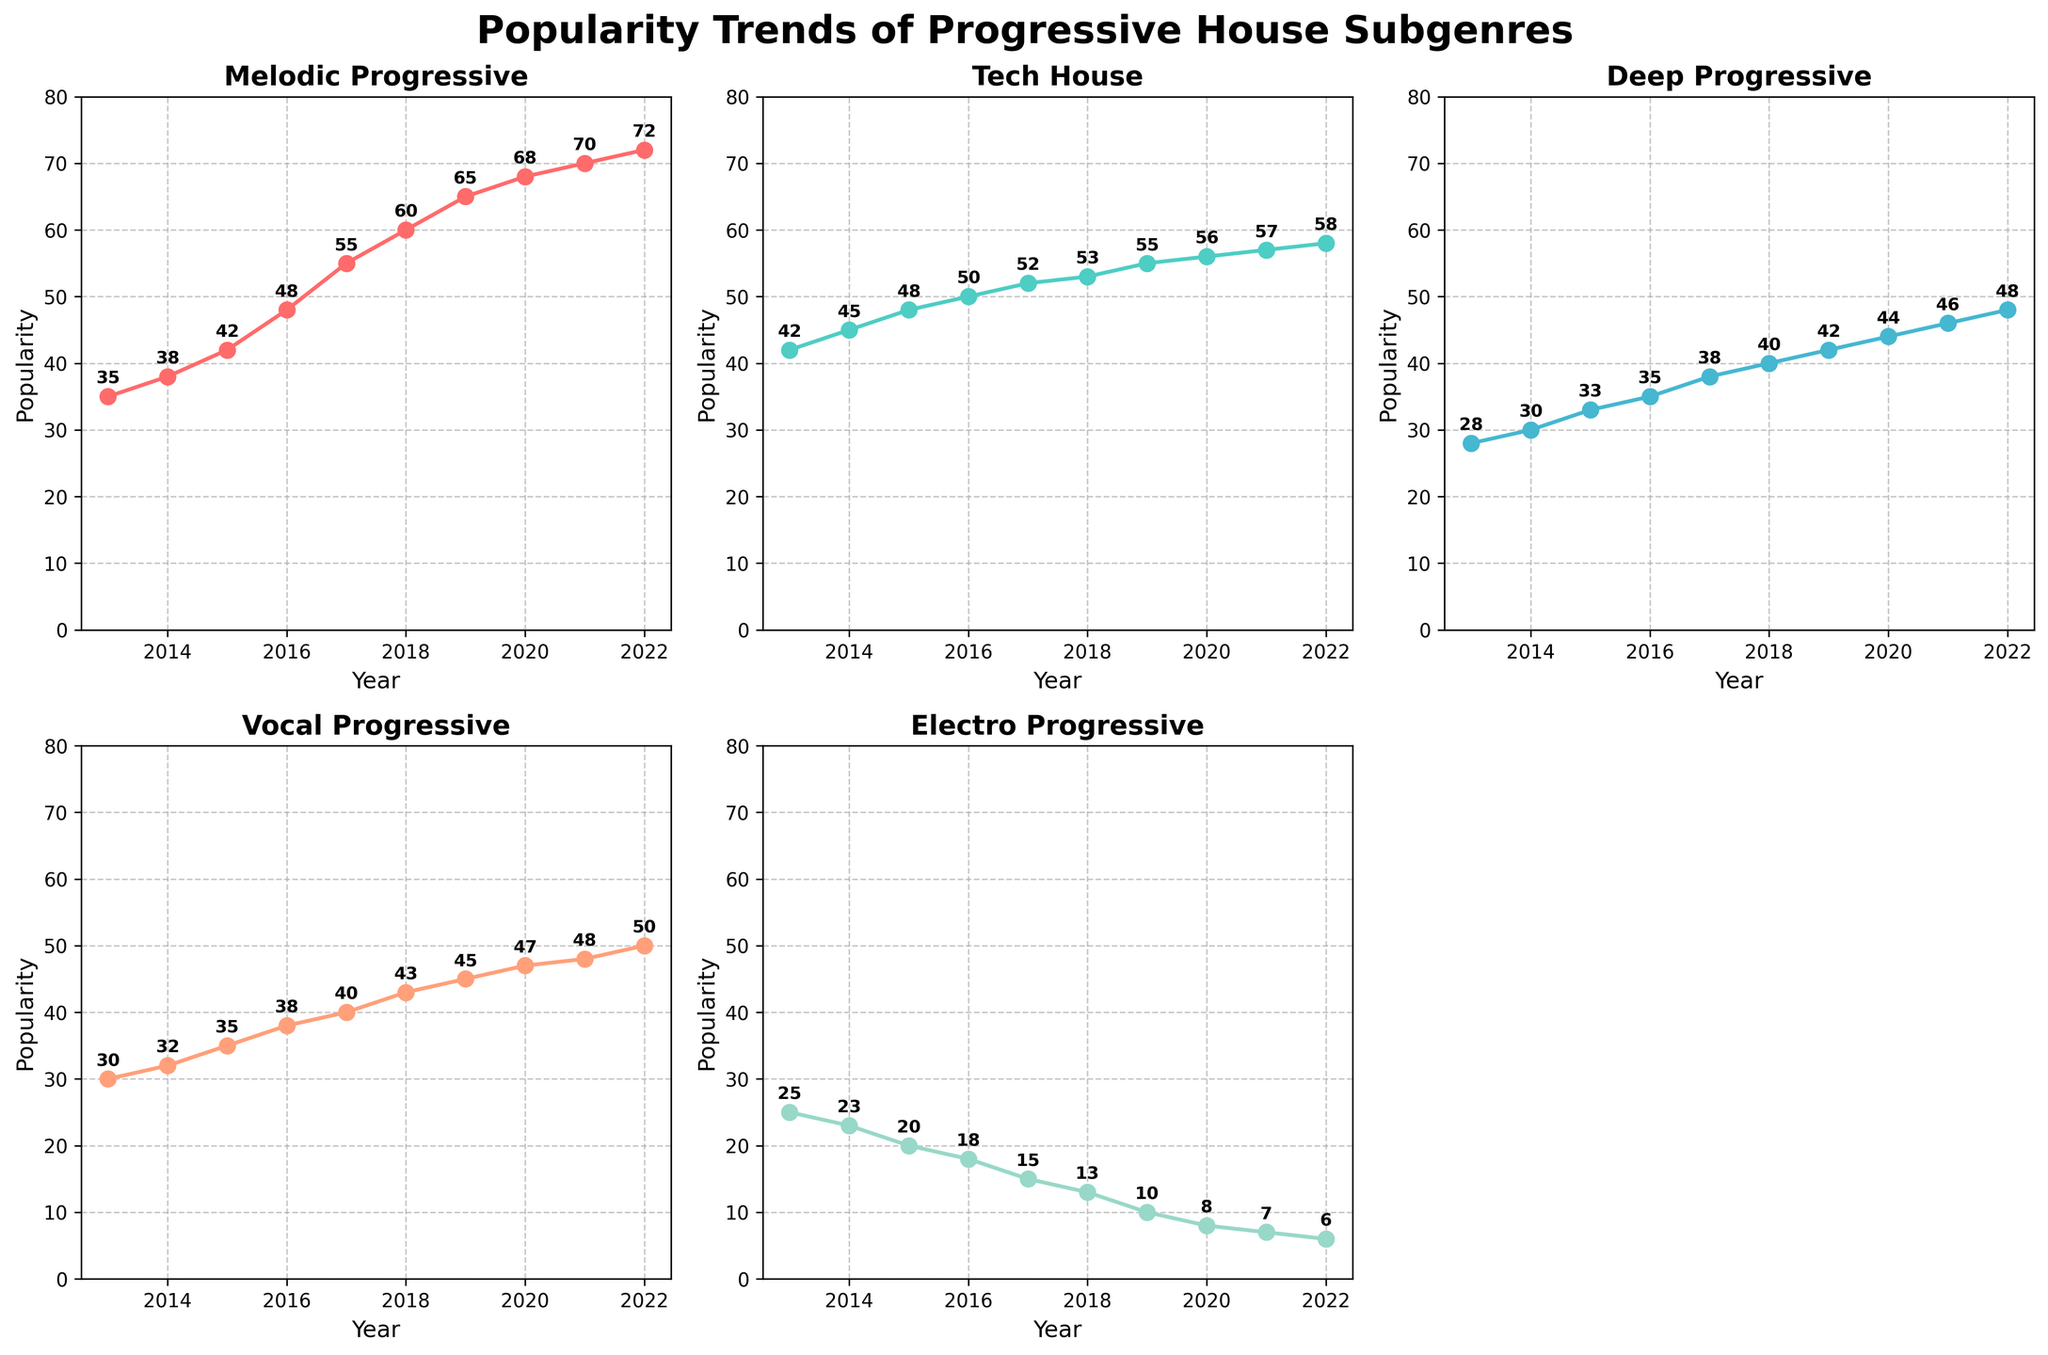What's the title of the figure? The title is displayed at the top of the figure. It reads "Popularity Trends of Progressive House Subgenres".
Answer: Popularity Trends of Progressive House Subgenres How many subplots are there in the figure? The figure consists of a grid where each progressive house subgenre has its own subplot. There are 5 subgenres, but one subplot is removed, making 5 subplots.
Answer: 5 subplots Which subgenre had the highest popularity in 2022? Look at the values for each subgenre in 2022. The Melodic Progressive subgenre reaches the highest value at 72.
Answer: Melodic Progressive What's the trend of the Deep Progressive subgenre from 2013 to 2022? Observe the values for the Deep Progressive subgenre across years. The trend shows a steady increase from 28 in 2013 to 48 in 2022.
Answer: Increasing trend What's the difference in popularity between Tech House and Electro Progressive in 2017? Compare the 2017 values for Tech House (52) and Electro Progressive (15). The difference is 52 - 15.
Answer: 37 Which subgenres show a decreasing trend over the years? Check the trends for all subgenres. Only the Electro Progressive subgenre shows a consistent decrease.
Answer: Electro Progressive What’s the average popularity of Vocal Progressive from 2013 to 2022? Sum the values for Vocal Progressive subgenre over the years (30 + 32 + 35 + 38 + 40 + 43 + 45 + 47 + 48 + 50) and divide by the number of years (10). The total is 408, and the average is 408/10.
Answer: 40.8 Which subgenre had the largest growth in popularity from 2013 to 2022? Calculate the growth for each subgenre. Subtract the 2013 value from the 2022 value for each subgenre and compare the results. The highest difference is for Melodic Progressive (72 - 35 = 37).
Answer: Melodic Progressive Which subplot title has the greenish blue plot line? By looking at the colors, the greenish blue plot line corresponds to the Deep Progressive subgenre.
Answer: Deep Progressive 